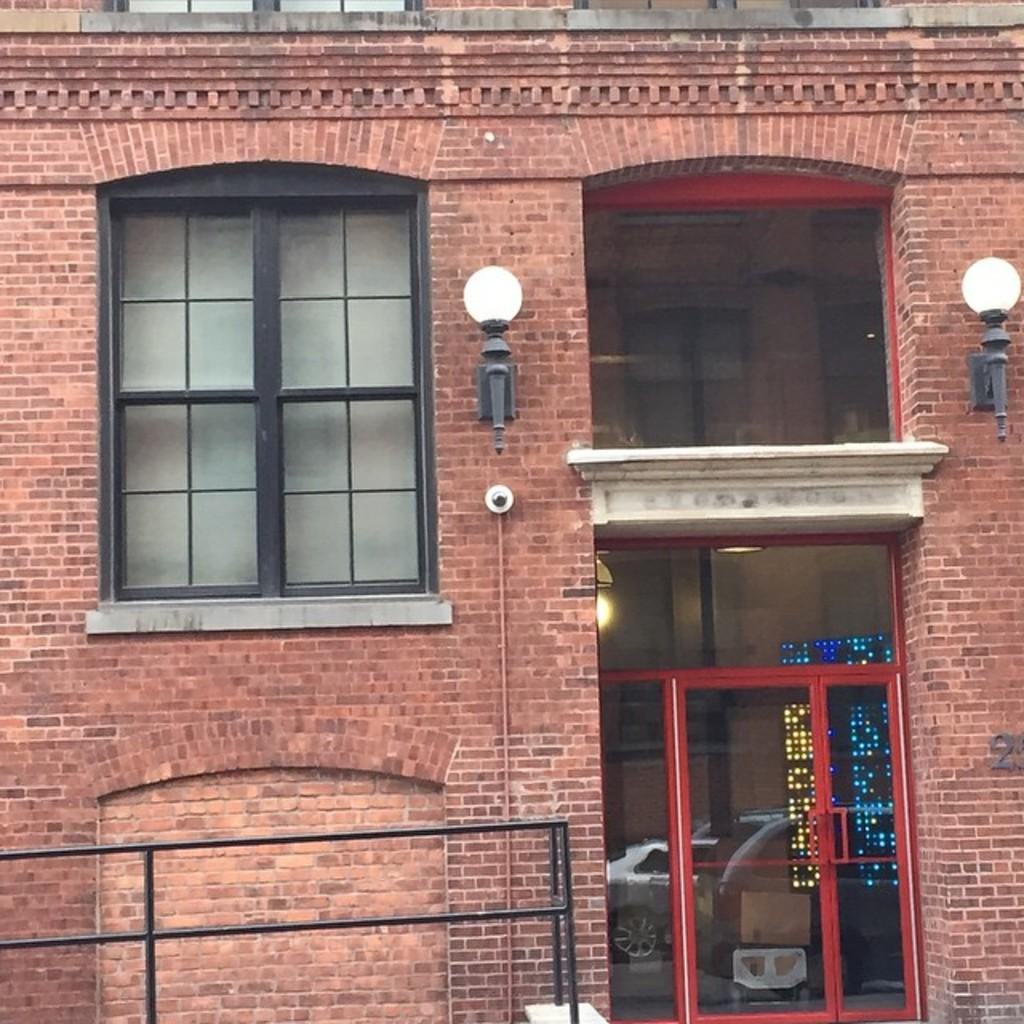What type of structure is present in the image? There is a building in the image. What features can be observed on the building? The building has windows, lights, and a glass door. Are there any other structures visible in the image? Yes, there are other buildings in the image. What else can be seen in the image besides the buildings? There are vehicles visible in the image. Can you tell me what type of juice is being served in the building? There is no mention of juice or any serving activity in the image; it primarily features buildings and vehicles. 